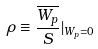Convert formula to latex. <formula><loc_0><loc_0><loc_500><loc_500>\rho \equiv \frac { \overline { W _ { p } } } { S } | _ { W _ { p } = 0 }</formula> 